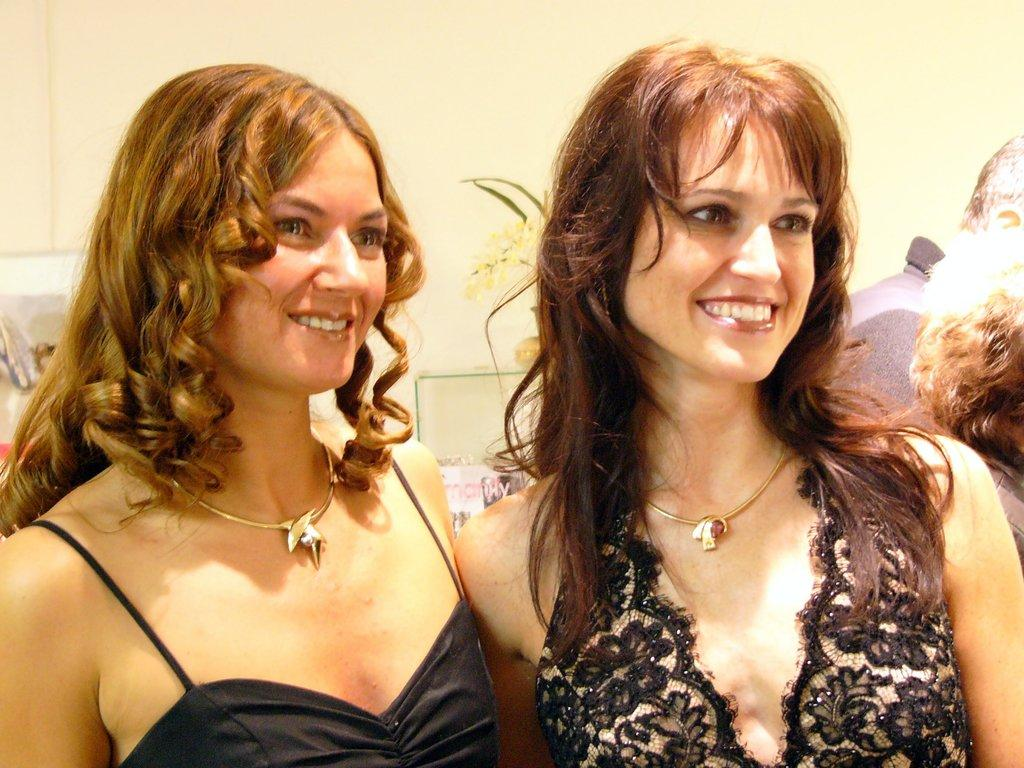How many people are in the image? There are persons in the image, but the exact number is not specified. What can be seen behind the persons in the image? There are objects visible behind the persons in the image. What type of structure is present in the image? There is a wall in the image. What type of can is visible on the wall in the image? There is no can visible on the wall in the image. Are there any wax figures present in the image? There is no mention of wax figures in the image. What type of dolls are sitting on the persons' laps in the image? There is no mention of dolls in the image. 